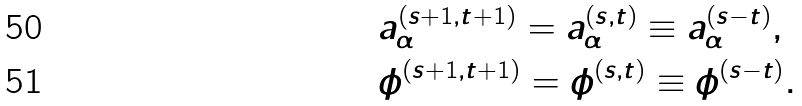<formula> <loc_0><loc_0><loc_500><loc_500>& a _ { \alpha } ^ { ( s + 1 , t + 1 ) } = a _ { \alpha } ^ { ( s , t ) } \equiv a _ { \alpha } ^ { ( s - t ) } , \\ & \phi ^ { ( s + 1 , t + 1 ) } = \phi ^ { ( s , t ) } \equiv \phi ^ { ( s - t ) } .</formula> 